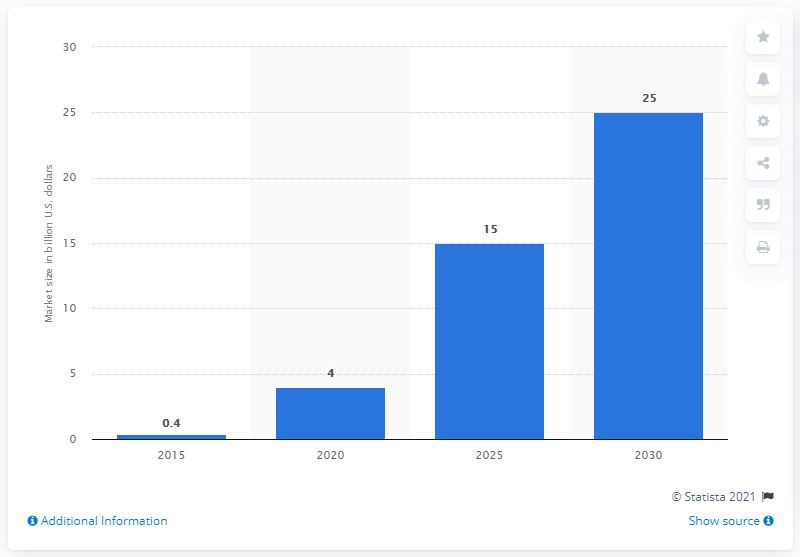Specify some key components in this picture. The market for autonomous driving sensor components is projected to reach 15 billion U.S. dollars by 2025. The market for autonomous driving sensor components is projected to reach $15 billion in 2025. 